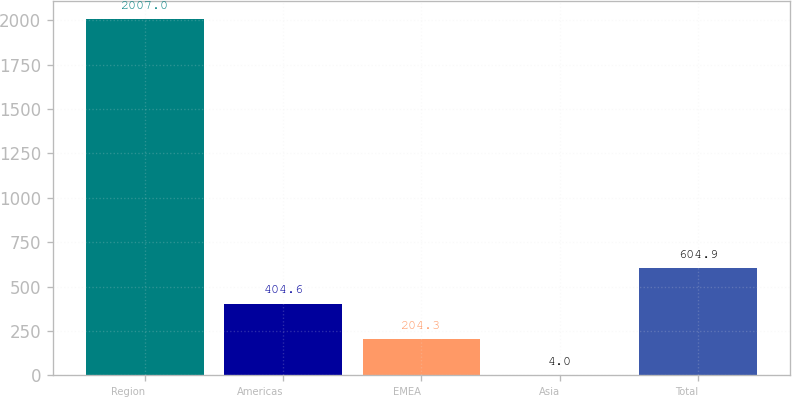Convert chart. <chart><loc_0><loc_0><loc_500><loc_500><bar_chart><fcel>Region<fcel>Americas<fcel>EMEA<fcel>Asia<fcel>Total<nl><fcel>2007<fcel>404.6<fcel>204.3<fcel>4<fcel>604.9<nl></chart> 